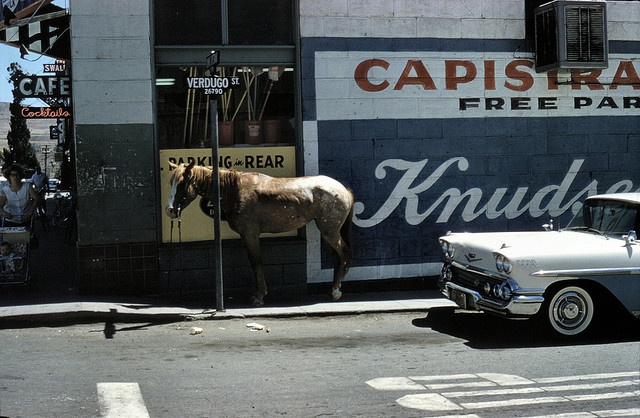Describe the objects in this image and their specific colors. I can see car in darkblue, black, white, gray, and darkgray tones, horse in darkblue, black, gray, and ivory tones, people in darkblue, black, and gray tones, people in darkblue, black, blue, and gray tones, and people in darkblue, black, and gray tones in this image. 